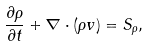<formula> <loc_0><loc_0><loc_500><loc_500>\frac { \partial \rho } { \partial t } + \nabla \cdot ( \rho v ) = S _ { \rho } ,</formula> 